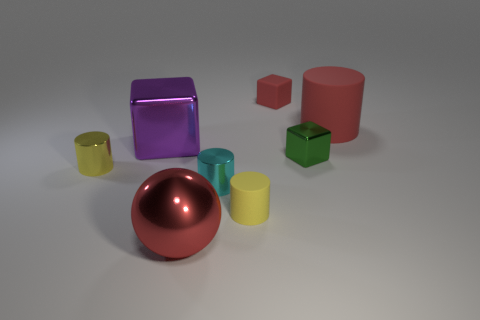Subtract all small rubber cylinders. How many cylinders are left? 3 Add 1 cylinders. How many objects exist? 9 Subtract all red blocks. How many blocks are left? 2 Subtract all blocks. How many objects are left? 5 Subtract 4 cylinders. How many cylinders are left? 0 Subtract all yellow spheres. Subtract all cyan cylinders. How many spheres are left? 1 Subtract all brown cubes. How many red cylinders are left? 1 Subtract all large metallic blocks. Subtract all large gray metal objects. How many objects are left? 7 Add 7 small matte cubes. How many small matte cubes are left? 8 Add 6 small yellow matte cylinders. How many small yellow matte cylinders exist? 7 